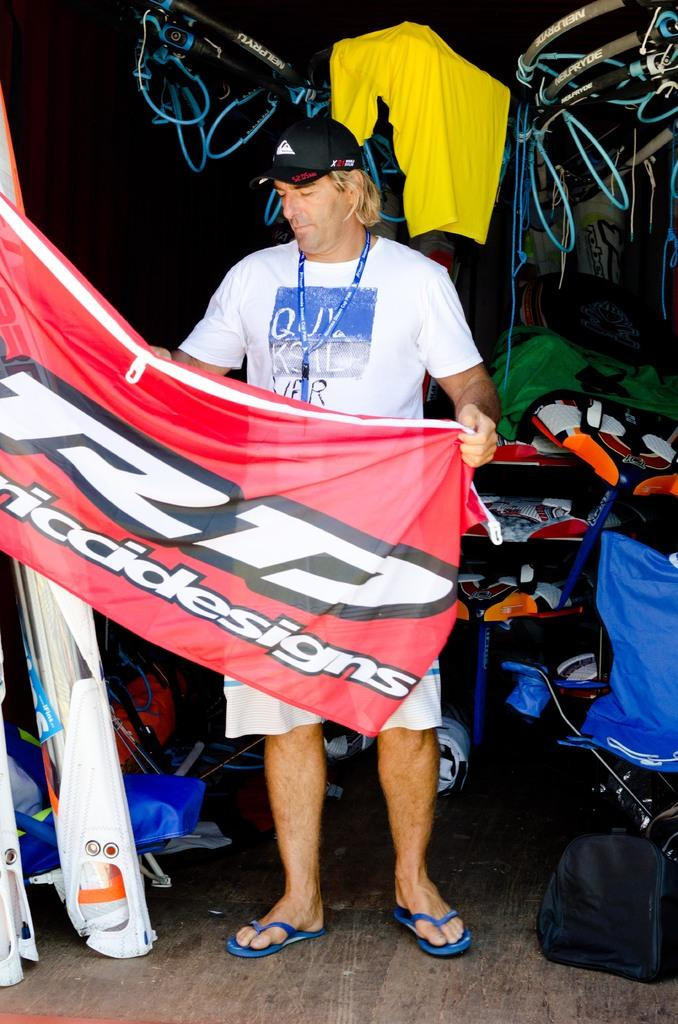Provide a one-sentence caption for the provided image. A man with a flag of RD seems some sort of sports flag. 